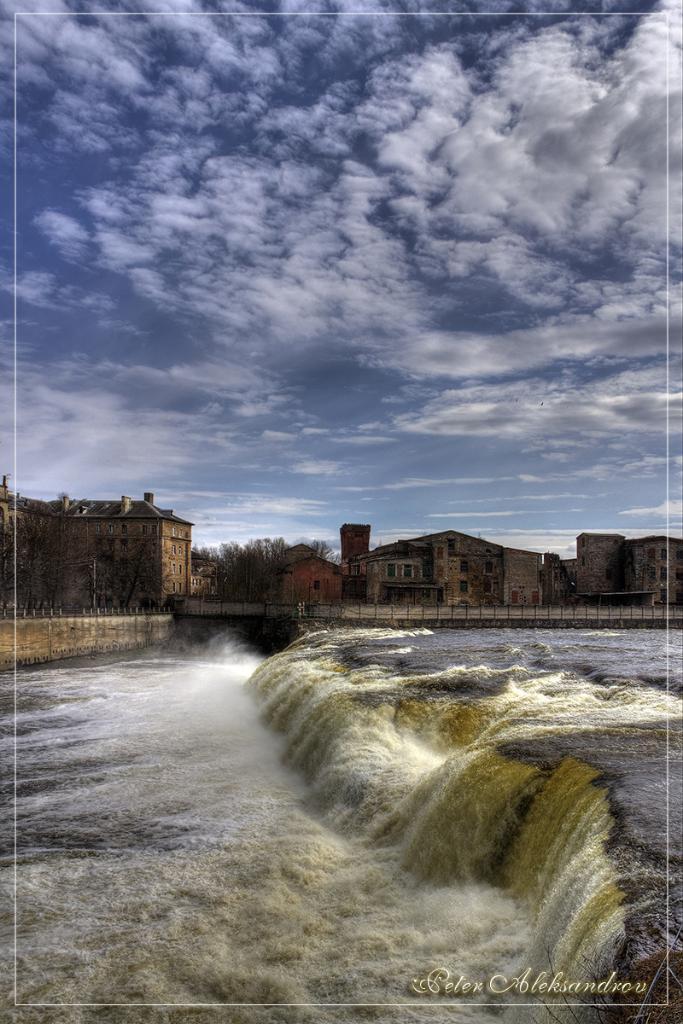How would you summarize this image in a sentence or two? In this picture I can see water, a bridge, buildings, trees, poles, and in the background there is sky and a watermark on the image. 